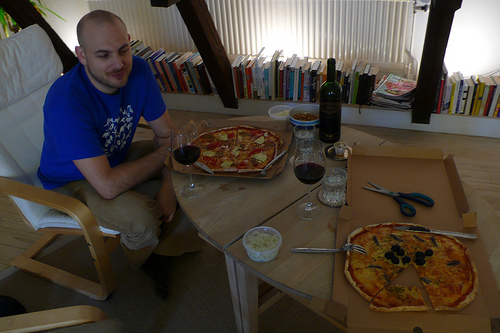<image>
Is the pizza on the table? Yes. Looking at the image, I can see the pizza is positioned on top of the table, with the table providing support. 